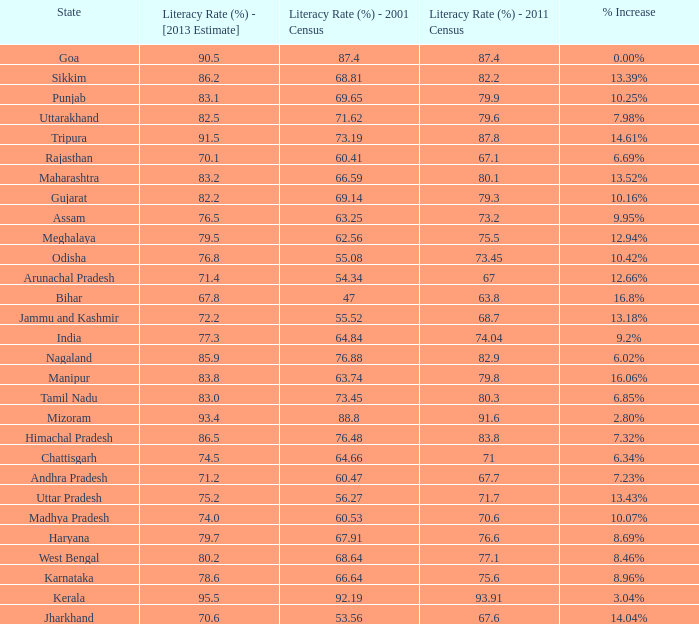What was the literacy rate published in the 2001 census for the state that saw a 12.66% increase? 54.34. 